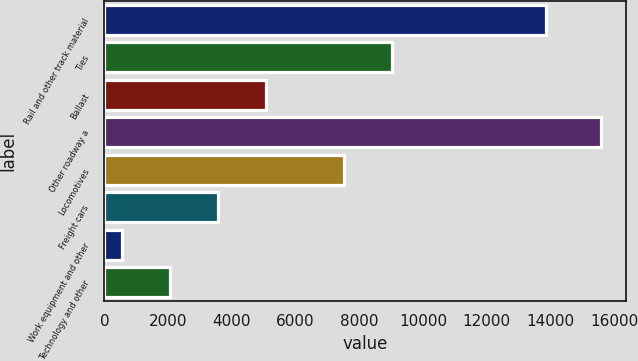<chart> <loc_0><loc_0><loc_500><loc_500><bar_chart><fcel>Rail and other track material<fcel>Ties<fcel>Ballast<fcel>Other roadway a<fcel>Locomotives<fcel>Freight cars<fcel>Work equipment and other<fcel>Technology and other<nl><fcel>13861<fcel>9021.5<fcel>5071.5<fcel>15596<fcel>7518<fcel>3568<fcel>561<fcel>2064.5<nl></chart> 